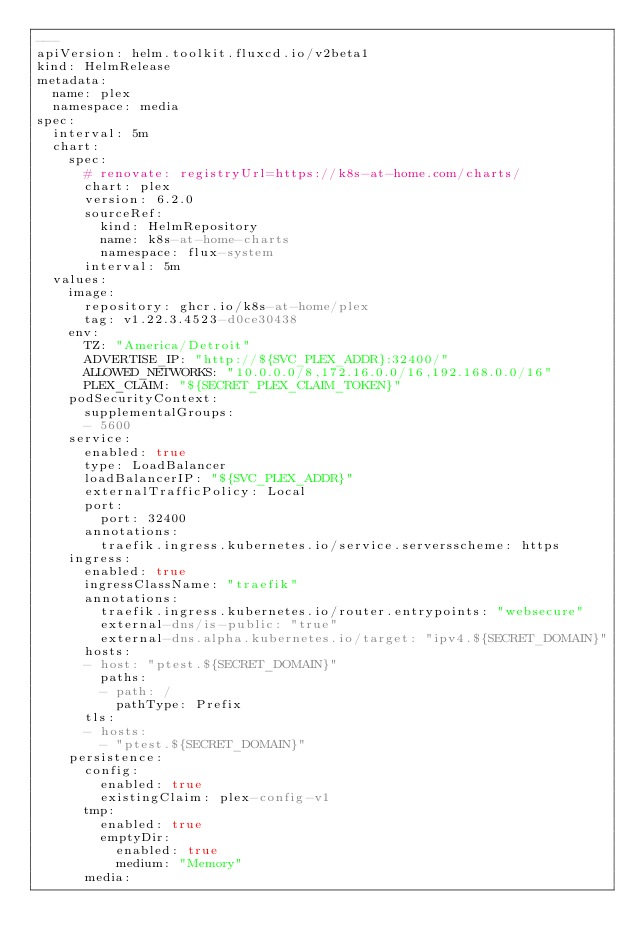Convert code to text. <code><loc_0><loc_0><loc_500><loc_500><_YAML_>---
apiVersion: helm.toolkit.fluxcd.io/v2beta1
kind: HelmRelease
metadata:
  name: plex
  namespace: media
spec:
  interval: 5m
  chart:
    spec:
      # renovate: registryUrl=https://k8s-at-home.com/charts/
      chart: plex
      version: 6.2.0
      sourceRef:
        kind: HelmRepository
        name: k8s-at-home-charts
        namespace: flux-system
      interval: 5m
  values:
    image:
      repository: ghcr.io/k8s-at-home/plex
      tag: v1.22.3.4523-d0ce30438
    env:
      TZ: "America/Detroit"
      ADVERTISE_IP: "http://${SVC_PLEX_ADDR}:32400/"
      ALLOWED_NETWORKS: "10.0.0.0/8,172.16.0.0/16,192.168.0.0/16"
      PLEX_CLAIM: "${SECRET_PLEX_CLAIM_TOKEN}"
    podSecurityContext:
      supplementalGroups:
      - 5600
    service:
      enabled: true
      type: LoadBalancer
      loadBalancerIP: "${SVC_PLEX_ADDR}"
      externalTrafficPolicy: Local
      port:
        port: 32400
      annotations:
        traefik.ingress.kubernetes.io/service.serversscheme: https
    ingress:
      enabled: true
      ingressClassName: "traefik"
      annotations:
        traefik.ingress.kubernetes.io/router.entrypoints: "websecure"
        external-dns/is-public: "true"
        external-dns.alpha.kubernetes.io/target: "ipv4.${SECRET_DOMAIN}"
      hosts:
      - host: "ptest.${SECRET_DOMAIN}"
        paths:
        - path: /
          pathType: Prefix
      tls:
      - hosts:
        - "ptest.${SECRET_DOMAIN}"
    persistence:
      config:
        enabled: true
        existingClaim: plex-config-v1
      tmp:
        enabled: true
        emptyDir:
          enabled: true
          medium: "Memory"
      media:</code> 